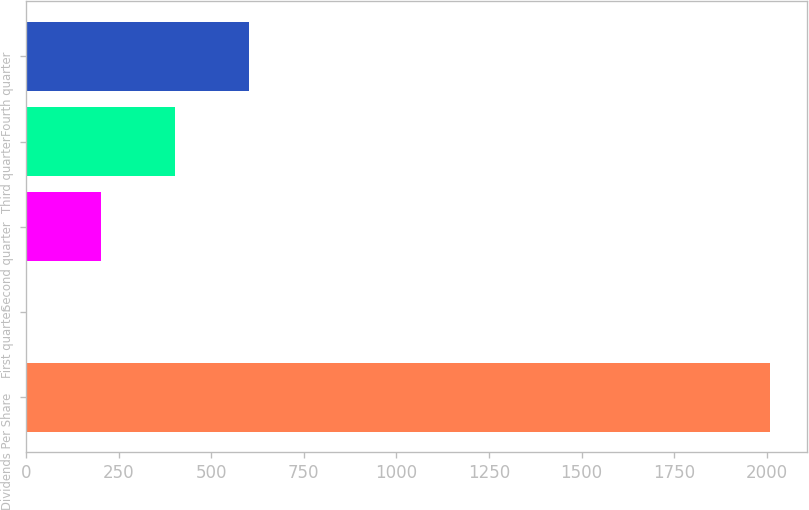<chart> <loc_0><loc_0><loc_500><loc_500><bar_chart><fcel>Dividends Per Share<fcel>First quarter<fcel>Second quarter<fcel>Third quarter<fcel>Fourth quarter<nl><fcel>2009<fcel>0.24<fcel>201.12<fcel>402<fcel>602.88<nl></chart> 